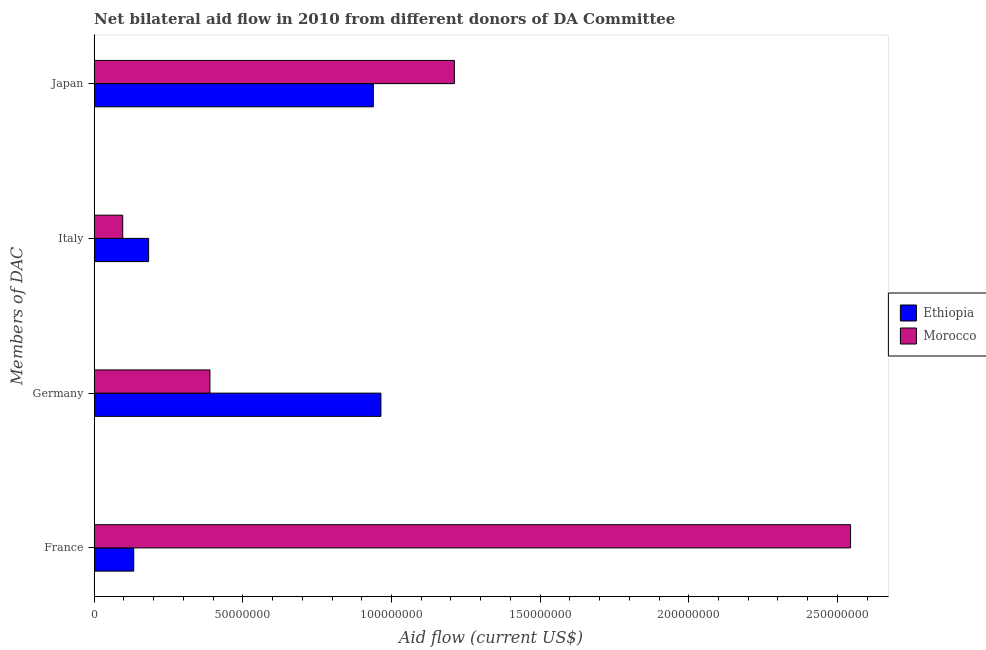How many different coloured bars are there?
Offer a very short reply. 2. How many groups of bars are there?
Provide a short and direct response. 4. Are the number of bars per tick equal to the number of legend labels?
Make the answer very short. Yes. Are the number of bars on each tick of the Y-axis equal?
Your answer should be very brief. Yes. How many bars are there on the 2nd tick from the bottom?
Offer a very short reply. 2. What is the amount of aid given by germany in Morocco?
Keep it short and to the point. 3.89e+07. Across all countries, what is the maximum amount of aid given by italy?
Provide a short and direct response. 1.83e+07. Across all countries, what is the minimum amount of aid given by japan?
Offer a very short reply. 9.39e+07. In which country was the amount of aid given by japan maximum?
Provide a short and direct response. Morocco. In which country was the amount of aid given by germany minimum?
Give a very brief answer. Morocco. What is the total amount of aid given by italy in the graph?
Your response must be concise. 2.79e+07. What is the difference between the amount of aid given by japan in Morocco and that in Ethiopia?
Make the answer very short. 2.73e+07. What is the difference between the amount of aid given by germany in Morocco and the amount of aid given by japan in Ethiopia?
Ensure brevity in your answer.  -5.50e+07. What is the average amount of aid given by france per country?
Your response must be concise. 1.34e+08. What is the difference between the amount of aid given by france and amount of aid given by germany in Ethiopia?
Ensure brevity in your answer.  -8.32e+07. What is the ratio of the amount of aid given by france in Morocco to that in Ethiopia?
Your response must be concise. 19.13. Is the amount of aid given by germany in Morocco less than that in Ethiopia?
Provide a short and direct response. Yes. Is the difference between the amount of aid given by france in Ethiopia and Morocco greater than the difference between the amount of aid given by italy in Ethiopia and Morocco?
Give a very brief answer. No. What is the difference between the highest and the second highest amount of aid given by japan?
Give a very brief answer. 2.73e+07. What is the difference between the highest and the lowest amount of aid given by france?
Make the answer very short. 2.41e+08. In how many countries, is the amount of aid given by germany greater than the average amount of aid given by germany taken over all countries?
Keep it short and to the point. 1. What does the 1st bar from the top in France represents?
Offer a terse response. Morocco. What does the 1st bar from the bottom in Japan represents?
Provide a short and direct response. Ethiopia. Is it the case that in every country, the sum of the amount of aid given by france and amount of aid given by germany is greater than the amount of aid given by italy?
Provide a succinct answer. Yes. How many bars are there?
Ensure brevity in your answer.  8. How many countries are there in the graph?
Your answer should be very brief. 2. What is the difference between two consecutive major ticks on the X-axis?
Give a very brief answer. 5.00e+07. Does the graph contain any zero values?
Ensure brevity in your answer.  No. Does the graph contain grids?
Offer a terse response. No. Where does the legend appear in the graph?
Offer a terse response. Center right. What is the title of the graph?
Keep it short and to the point. Net bilateral aid flow in 2010 from different donors of DA Committee. What is the label or title of the X-axis?
Provide a short and direct response. Aid flow (current US$). What is the label or title of the Y-axis?
Offer a terse response. Members of DAC. What is the Aid flow (current US$) in Ethiopia in France?
Ensure brevity in your answer.  1.33e+07. What is the Aid flow (current US$) in Morocco in France?
Make the answer very short. 2.54e+08. What is the Aid flow (current US$) in Ethiopia in Germany?
Give a very brief answer. 9.64e+07. What is the Aid flow (current US$) in Morocco in Germany?
Provide a succinct answer. 3.89e+07. What is the Aid flow (current US$) of Ethiopia in Italy?
Offer a very short reply. 1.83e+07. What is the Aid flow (current US$) of Morocco in Italy?
Your response must be concise. 9.60e+06. What is the Aid flow (current US$) in Ethiopia in Japan?
Offer a terse response. 9.39e+07. What is the Aid flow (current US$) in Morocco in Japan?
Provide a short and direct response. 1.21e+08. Across all Members of DAC, what is the maximum Aid flow (current US$) of Ethiopia?
Offer a terse response. 9.64e+07. Across all Members of DAC, what is the maximum Aid flow (current US$) of Morocco?
Make the answer very short. 2.54e+08. Across all Members of DAC, what is the minimum Aid flow (current US$) in Ethiopia?
Provide a short and direct response. 1.33e+07. Across all Members of DAC, what is the minimum Aid flow (current US$) of Morocco?
Your answer should be very brief. 9.60e+06. What is the total Aid flow (current US$) of Ethiopia in the graph?
Your response must be concise. 2.22e+08. What is the total Aid flow (current US$) in Morocco in the graph?
Make the answer very short. 4.24e+08. What is the difference between the Aid flow (current US$) in Ethiopia in France and that in Germany?
Offer a terse response. -8.32e+07. What is the difference between the Aid flow (current US$) in Morocco in France and that in Germany?
Your answer should be very brief. 2.15e+08. What is the difference between the Aid flow (current US$) of Ethiopia in France and that in Italy?
Your response must be concise. -5.01e+06. What is the difference between the Aid flow (current US$) in Morocco in France and that in Italy?
Keep it short and to the point. 2.45e+08. What is the difference between the Aid flow (current US$) of Ethiopia in France and that in Japan?
Keep it short and to the point. -8.06e+07. What is the difference between the Aid flow (current US$) of Morocco in France and that in Japan?
Your response must be concise. 1.33e+08. What is the difference between the Aid flow (current US$) of Ethiopia in Germany and that in Italy?
Your response must be concise. 7.81e+07. What is the difference between the Aid flow (current US$) of Morocco in Germany and that in Italy?
Ensure brevity in your answer.  2.93e+07. What is the difference between the Aid flow (current US$) of Ethiopia in Germany and that in Japan?
Ensure brevity in your answer.  2.56e+06. What is the difference between the Aid flow (current US$) of Morocco in Germany and that in Japan?
Ensure brevity in your answer.  -8.22e+07. What is the difference between the Aid flow (current US$) in Ethiopia in Italy and that in Japan?
Provide a succinct answer. -7.56e+07. What is the difference between the Aid flow (current US$) in Morocco in Italy and that in Japan?
Your answer should be very brief. -1.12e+08. What is the difference between the Aid flow (current US$) in Ethiopia in France and the Aid flow (current US$) in Morocco in Germany?
Your answer should be compact. -2.56e+07. What is the difference between the Aid flow (current US$) of Ethiopia in France and the Aid flow (current US$) of Morocco in Italy?
Provide a succinct answer. 3.70e+06. What is the difference between the Aid flow (current US$) in Ethiopia in France and the Aid flow (current US$) in Morocco in Japan?
Ensure brevity in your answer.  -1.08e+08. What is the difference between the Aid flow (current US$) of Ethiopia in Germany and the Aid flow (current US$) of Morocco in Italy?
Provide a succinct answer. 8.68e+07. What is the difference between the Aid flow (current US$) of Ethiopia in Germany and the Aid flow (current US$) of Morocco in Japan?
Your answer should be compact. -2.47e+07. What is the difference between the Aid flow (current US$) in Ethiopia in Italy and the Aid flow (current US$) in Morocco in Japan?
Ensure brevity in your answer.  -1.03e+08. What is the average Aid flow (current US$) of Ethiopia per Members of DAC?
Provide a short and direct response. 5.55e+07. What is the average Aid flow (current US$) in Morocco per Members of DAC?
Offer a very short reply. 1.06e+08. What is the difference between the Aid flow (current US$) of Ethiopia and Aid flow (current US$) of Morocco in France?
Make the answer very short. -2.41e+08. What is the difference between the Aid flow (current US$) in Ethiopia and Aid flow (current US$) in Morocco in Germany?
Your answer should be very brief. 5.75e+07. What is the difference between the Aid flow (current US$) in Ethiopia and Aid flow (current US$) in Morocco in Italy?
Make the answer very short. 8.71e+06. What is the difference between the Aid flow (current US$) of Ethiopia and Aid flow (current US$) of Morocco in Japan?
Offer a very short reply. -2.73e+07. What is the ratio of the Aid flow (current US$) of Ethiopia in France to that in Germany?
Make the answer very short. 0.14. What is the ratio of the Aid flow (current US$) of Morocco in France to that in Germany?
Keep it short and to the point. 6.53. What is the ratio of the Aid flow (current US$) of Ethiopia in France to that in Italy?
Give a very brief answer. 0.73. What is the ratio of the Aid flow (current US$) of Morocco in France to that in Italy?
Your answer should be very brief. 26.5. What is the ratio of the Aid flow (current US$) in Ethiopia in France to that in Japan?
Offer a very short reply. 0.14. What is the ratio of the Aid flow (current US$) in Morocco in France to that in Japan?
Offer a very short reply. 2.1. What is the ratio of the Aid flow (current US$) in Ethiopia in Germany to that in Italy?
Make the answer very short. 5.27. What is the ratio of the Aid flow (current US$) in Morocco in Germany to that in Italy?
Your response must be concise. 4.06. What is the ratio of the Aid flow (current US$) of Ethiopia in Germany to that in Japan?
Offer a terse response. 1.03. What is the ratio of the Aid flow (current US$) of Morocco in Germany to that in Japan?
Offer a very short reply. 0.32. What is the ratio of the Aid flow (current US$) of Ethiopia in Italy to that in Japan?
Offer a terse response. 0.2. What is the ratio of the Aid flow (current US$) of Morocco in Italy to that in Japan?
Offer a terse response. 0.08. What is the difference between the highest and the second highest Aid flow (current US$) in Ethiopia?
Offer a terse response. 2.56e+06. What is the difference between the highest and the second highest Aid flow (current US$) in Morocco?
Your answer should be compact. 1.33e+08. What is the difference between the highest and the lowest Aid flow (current US$) in Ethiopia?
Ensure brevity in your answer.  8.32e+07. What is the difference between the highest and the lowest Aid flow (current US$) in Morocco?
Make the answer very short. 2.45e+08. 